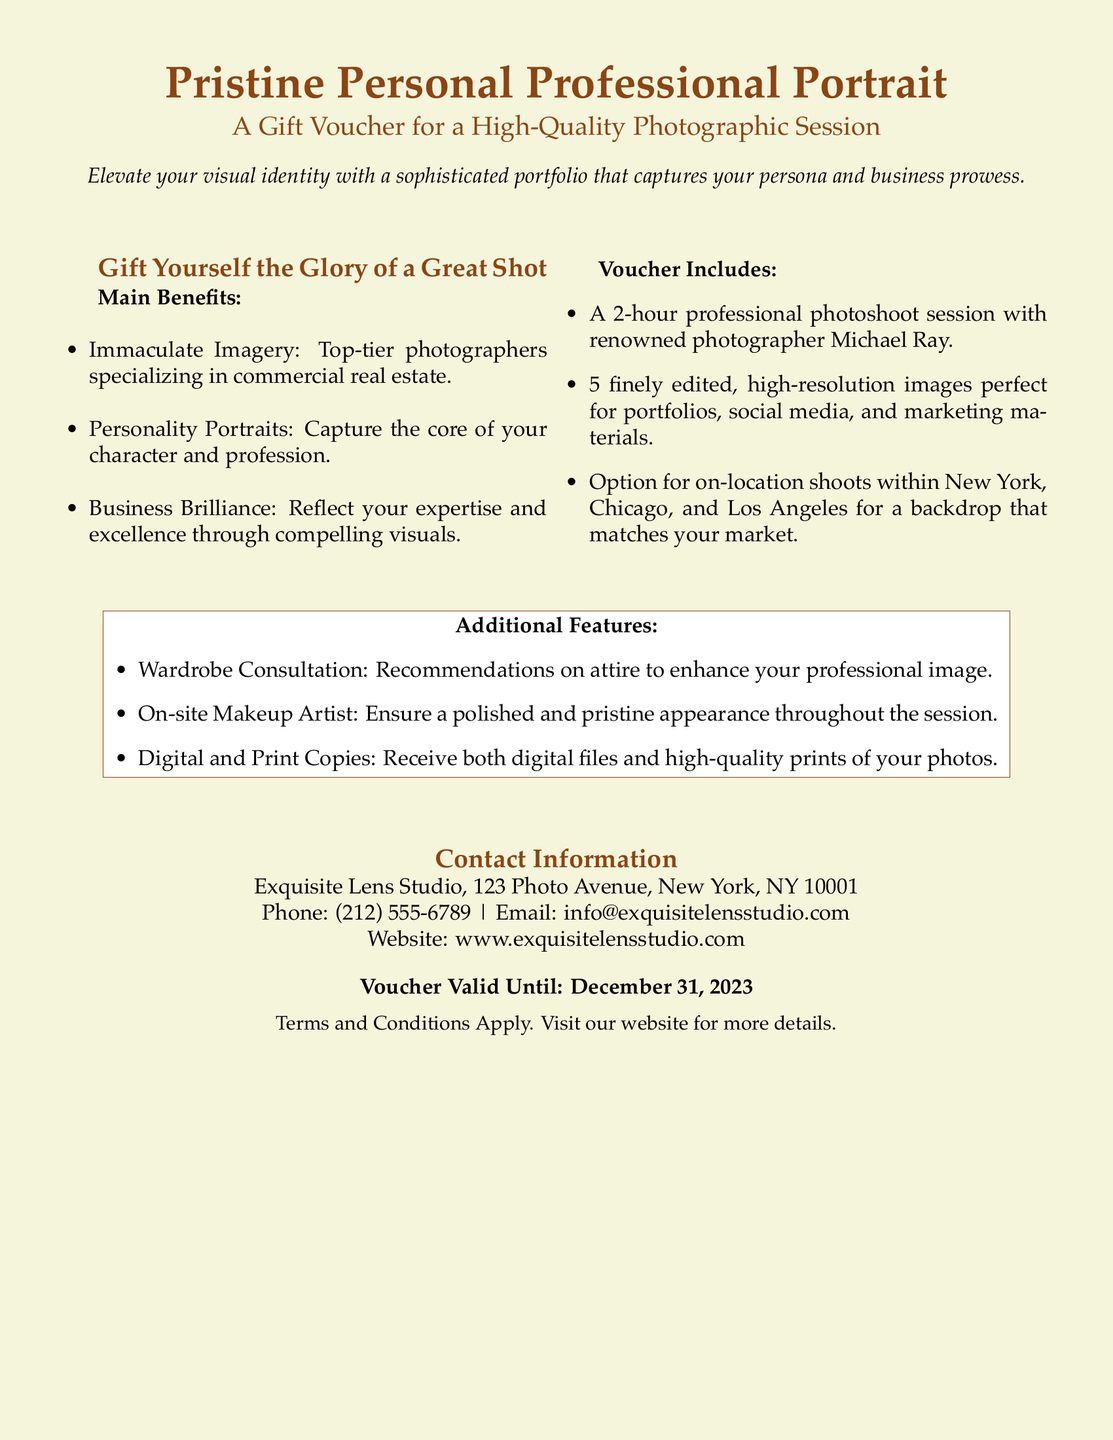what is the name of the service offered? The service offered is called "Pristine Personal Professional Portrait."
Answer: Pristine Personal Professional Portrait who is the photographer mentioned in the voucher? The voucher mentions photographer Michael Ray.
Answer: Michael Ray how many high-resolution images are included in the voucher? The voucher includes 5 finely edited high-resolution images.
Answer: 5 what is the duration of the professional photoshoot session? The professional photoshoot session lasts for 2 hours.
Answer: 2 hours which cities are specified for on-location shoots? The specified cities for on-location shoots are New York, Chicago, and Los Angeles.
Answer: New York, Chicago, Los Angeles what kind of consultation is offered as an additional feature? The voucher includes a wardrobe consultation.
Answer: Wardrobe Consultation when is the voucher valid until? The voucher is valid until December 31, 2023.
Answer: December 31, 2023 what type of appearance assistance is provided during the session? An on-site makeup artist is provided for appearance assistance.
Answer: On-site Makeup Artist what contact method is provided for inquiries? The contact methods provided include phone and email.
Answer: Phone and Email 